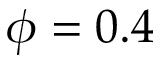<formula> <loc_0><loc_0><loc_500><loc_500>\phi = 0 . 4</formula> 